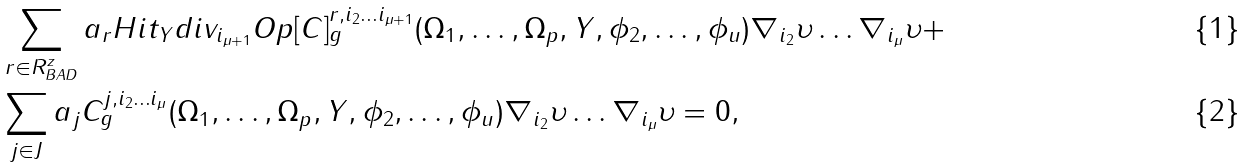Convert formula to latex. <formula><loc_0><loc_0><loc_500><loc_500>& \sum _ { r \in R ^ { z } _ { B A D } } a _ { r } H i t _ { Y } d i v _ { i _ { \mu + 1 } } O p [ C ] ^ { r , i _ { 2 } \dots i _ { \mu + 1 } } _ { g } ( \Omega _ { 1 } , \dots , \Omega _ { p } , Y , \phi _ { 2 } , \dots , \phi _ { u } ) \nabla _ { i _ { 2 } } \upsilon \dots \nabla _ { i _ { \mu } } \upsilon + \\ & \sum _ { j \in J } a _ { j } C ^ { j , i _ { 2 } \dots i _ { \mu } } _ { g } ( \Omega _ { 1 } , \dots , \Omega _ { p } , Y , \phi _ { 2 } , \dots , \phi _ { u } ) \nabla _ { i _ { 2 } } \upsilon \dots \nabla _ { i _ { \mu } } \upsilon = 0 ,</formula> 